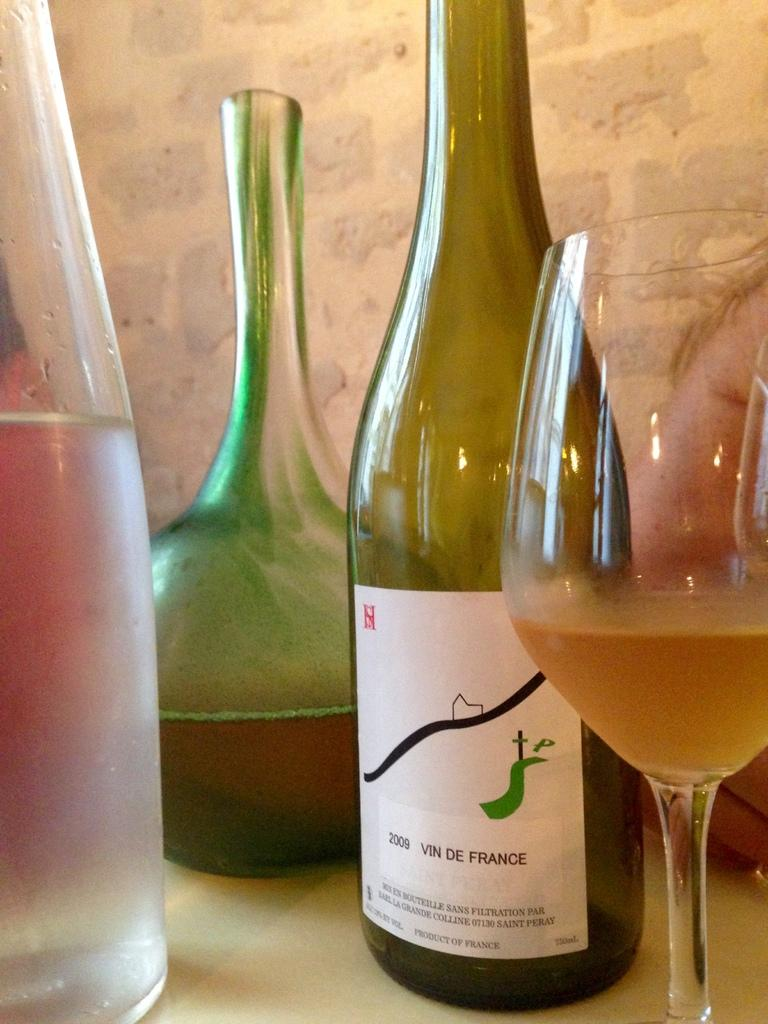What objects in the image are related to beverages? There are bottles and a glass with some drink in it. Can you describe the glass with a drink in more detail? The glass has some drink in it, but the specific type of drink is not mentioned in the facts. How many cows are visible in the image? There are no cows present in the image. 